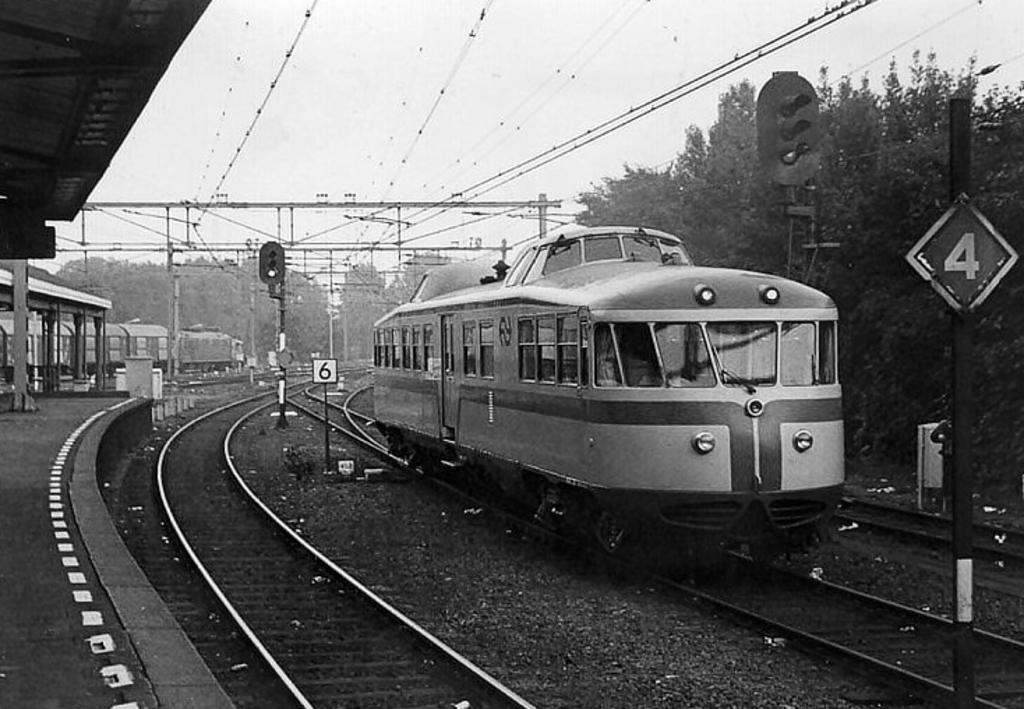What is the main subject of the image? The main subject of the image is a train moving on the railway track. What else can be seen in the image besides the train? There is a platform, signal poles, wires, another train, trees, and the sky visible in the image. Can you describe the location of the other train in the image? The other train is on a parallel railway track. What is visible in the background of the image? Trees and the sky are visible in the background of the image. What type of comb is being used by the nut in the image? There are no nuts or combs present in the image. 